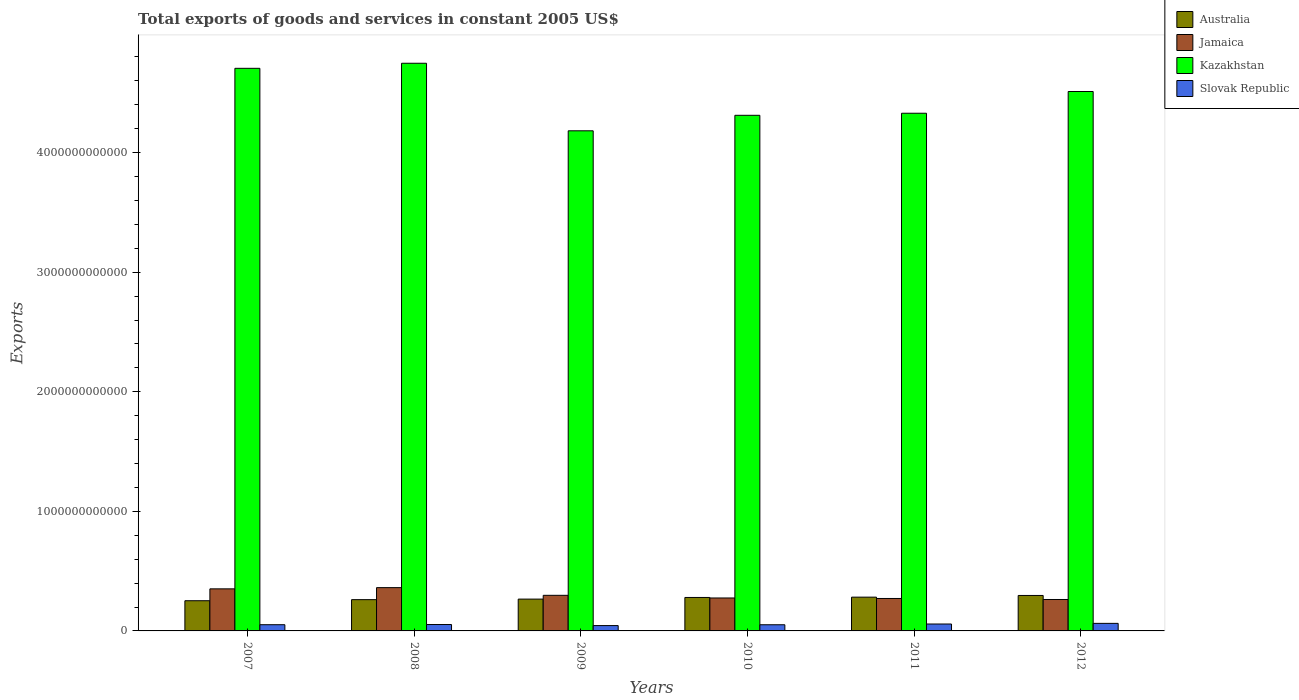How many different coloured bars are there?
Your answer should be compact. 4. Are the number of bars per tick equal to the number of legend labels?
Keep it short and to the point. Yes. How many bars are there on the 6th tick from the left?
Give a very brief answer. 4. What is the total exports of goods and services in Slovak Republic in 2010?
Ensure brevity in your answer.  5.16e+1. Across all years, what is the maximum total exports of goods and services in Australia?
Your answer should be very brief. 2.96e+11. Across all years, what is the minimum total exports of goods and services in Slovak Republic?
Make the answer very short. 4.46e+1. What is the total total exports of goods and services in Kazakhstan in the graph?
Give a very brief answer. 2.68e+13. What is the difference between the total exports of goods and services in Australia in 2008 and that in 2011?
Your answer should be very brief. -2.09e+1. What is the difference between the total exports of goods and services in Kazakhstan in 2007 and the total exports of goods and services in Slovak Republic in 2012?
Give a very brief answer. 4.64e+12. What is the average total exports of goods and services in Kazakhstan per year?
Keep it short and to the point. 4.46e+12. In the year 2009, what is the difference between the total exports of goods and services in Australia and total exports of goods and services in Slovak Republic?
Your answer should be very brief. 2.22e+11. In how many years, is the total exports of goods and services in Slovak Republic greater than 3200000000000 US$?
Offer a terse response. 0. What is the ratio of the total exports of goods and services in Australia in 2008 to that in 2012?
Your answer should be compact. 0.88. Is the difference between the total exports of goods and services in Australia in 2008 and 2011 greater than the difference between the total exports of goods and services in Slovak Republic in 2008 and 2011?
Provide a short and direct response. No. What is the difference between the highest and the second highest total exports of goods and services in Australia?
Offer a terse response. 1.41e+1. What is the difference between the highest and the lowest total exports of goods and services in Jamaica?
Give a very brief answer. 9.93e+1. In how many years, is the total exports of goods and services in Australia greater than the average total exports of goods and services in Australia taken over all years?
Offer a very short reply. 3. Is it the case that in every year, the sum of the total exports of goods and services in Slovak Republic and total exports of goods and services in Jamaica is greater than the sum of total exports of goods and services in Kazakhstan and total exports of goods and services in Australia?
Offer a terse response. Yes. What does the 3rd bar from the left in 2009 represents?
Offer a terse response. Kazakhstan. What does the 3rd bar from the right in 2007 represents?
Your response must be concise. Jamaica. Is it the case that in every year, the sum of the total exports of goods and services in Slovak Republic and total exports of goods and services in Australia is greater than the total exports of goods and services in Jamaica?
Your answer should be very brief. No. How many bars are there?
Keep it short and to the point. 24. Are all the bars in the graph horizontal?
Make the answer very short. No. What is the difference between two consecutive major ticks on the Y-axis?
Provide a succinct answer. 1.00e+12. Does the graph contain any zero values?
Offer a terse response. No. What is the title of the graph?
Your answer should be compact. Total exports of goods and services in constant 2005 US$. Does "Canada" appear as one of the legend labels in the graph?
Ensure brevity in your answer.  No. What is the label or title of the Y-axis?
Offer a terse response. Exports. What is the Exports in Australia in 2007?
Offer a very short reply. 2.53e+11. What is the Exports in Jamaica in 2007?
Provide a short and direct response. 3.52e+11. What is the Exports in Kazakhstan in 2007?
Give a very brief answer. 4.70e+12. What is the Exports in Slovak Republic in 2007?
Keep it short and to the point. 5.20e+1. What is the Exports of Australia in 2008?
Give a very brief answer. 2.62e+11. What is the Exports of Jamaica in 2008?
Ensure brevity in your answer.  3.62e+11. What is the Exports in Kazakhstan in 2008?
Keep it short and to the point. 4.75e+12. What is the Exports of Slovak Republic in 2008?
Offer a very short reply. 5.35e+1. What is the Exports of Australia in 2009?
Offer a terse response. 2.66e+11. What is the Exports in Jamaica in 2009?
Your answer should be compact. 2.98e+11. What is the Exports in Kazakhstan in 2009?
Provide a short and direct response. 4.18e+12. What is the Exports of Slovak Republic in 2009?
Provide a succinct answer. 4.46e+1. What is the Exports of Australia in 2010?
Keep it short and to the point. 2.80e+11. What is the Exports in Jamaica in 2010?
Give a very brief answer. 2.76e+11. What is the Exports in Kazakhstan in 2010?
Give a very brief answer. 4.31e+12. What is the Exports of Slovak Republic in 2010?
Provide a succinct answer. 5.16e+1. What is the Exports of Australia in 2011?
Your response must be concise. 2.82e+11. What is the Exports in Jamaica in 2011?
Your response must be concise. 2.71e+11. What is the Exports of Kazakhstan in 2011?
Ensure brevity in your answer.  4.33e+12. What is the Exports of Slovak Republic in 2011?
Offer a terse response. 5.78e+1. What is the Exports in Australia in 2012?
Make the answer very short. 2.96e+11. What is the Exports in Jamaica in 2012?
Your answer should be very brief. 2.63e+11. What is the Exports in Kazakhstan in 2012?
Provide a short and direct response. 4.51e+12. What is the Exports of Slovak Republic in 2012?
Make the answer very short. 6.32e+1. Across all years, what is the maximum Exports in Australia?
Ensure brevity in your answer.  2.96e+11. Across all years, what is the maximum Exports of Jamaica?
Provide a short and direct response. 3.62e+11. Across all years, what is the maximum Exports of Kazakhstan?
Provide a succinct answer. 4.75e+12. Across all years, what is the maximum Exports of Slovak Republic?
Make the answer very short. 6.32e+1. Across all years, what is the minimum Exports in Australia?
Your answer should be compact. 2.53e+11. Across all years, what is the minimum Exports of Jamaica?
Offer a terse response. 2.63e+11. Across all years, what is the minimum Exports in Kazakhstan?
Give a very brief answer. 4.18e+12. Across all years, what is the minimum Exports in Slovak Republic?
Your response must be concise. 4.46e+1. What is the total Exports of Australia in the graph?
Make the answer very short. 1.64e+12. What is the total Exports in Jamaica in the graph?
Provide a short and direct response. 1.82e+12. What is the total Exports of Kazakhstan in the graph?
Make the answer very short. 2.68e+13. What is the total Exports of Slovak Republic in the graph?
Your answer should be very brief. 3.23e+11. What is the difference between the Exports in Australia in 2007 and that in 2008?
Give a very brief answer. -8.97e+09. What is the difference between the Exports in Jamaica in 2007 and that in 2008?
Provide a short and direct response. -1.02e+1. What is the difference between the Exports of Kazakhstan in 2007 and that in 2008?
Offer a very short reply. -4.23e+1. What is the difference between the Exports of Slovak Republic in 2007 and that in 2008?
Offer a very short reply. -1.57e+09. What is the difference between the Exports of Australia in 2007 and that in 2009?
Provide a succinct answer. -1.36e+1. What is the difference between the Exports in Jamaica in 2007 and that in 2009?
Your answer should be very brief. 5.41e+1. What is the difference between the Exports in Kazakhstan in 2007 and that in 2009?
Your answer should be compact. 5.23e+11. What is the difference between the Exports of Slovak Republic in 2007 and that in 2009?
Your response must be concise. 7.41e+09. What is the difference between the Exports of Australia in 2007 and that in 2010?
Provide a succinct answer. -2.72e+1. What is the difference between the Exports of Jamaica in 2007 and that in 2010?
Ensure brevity in your answer.  7.63e+1. What is the difference between the Exports of Kazakhstan in 2007 and that in 2010?
Your response must be concise. 3.93e+11. What is the difference between the Exports in Slovak Republic in 2007 and that in 2010?
Provide a short and direct response. 3.94e+08. What is the difference between the Exports in Australia in 2007 and that in 2011?
Your response must be concise. -2.98e+1. What is the difference between the Exports of Jamaica in 2007 and that in 2011?
Provide a short and direct response. 8.05e+1. What is the difference between the Exports of Kazakhstan in 2007 and that in 2011?
Make the answer very short. 3.76e+11. What is the difference between the Exports in Slovak Republic in 2007 and that in 2011?
Offer a terse response. -5.80e+09. What is the difference between the Exports of Australia in 2007 and that in 2012?
Provide a succinct answer. -4.40e+1. What is the difference between the Exports in Jamaica in 2007 and that in 2012?
Ensure brevity in your answer.  8.91e+1. What is the difference between the Exports of Kazakhstan in 2007 and that in 2012?
Keep it short and to the point. 1.94e+11. What is the difference between the Exports in Slovak Republic in 2007 and that in 2012?
Ensure brevity in your answer.  -1.12e+1. What is the difference between the Exports of Australia in 2008 and that in 2009?
Your answer should be compact. -4.58e+09. What is the difference between the Exports of Jamaica in 2008 and that in 2009?
Keep it short and to the point. 6.43e+1. What is the difference between the Exports in Kazakhstan in 2008 and that in 2009?
Offer a terse response. 5.65e+11. What is the difference between the Exports of Slovak Republic in 2008 and that in 2009?
Your answer should be compact. 8.98e+09. What is the difference between the Exports in Australia in 2008 and that in 2010?
Your answer should be compact. -1.83e+1. What is the difference between the Exports of Jamaica in 2008 and that in 2010?
Your response must be concise. 8.65e+1. What is the difference between the Exports in Kazakhstan in 2008 and that in 2010?
Your answer should be very brief. 4.35e+11. What is the difference between the Exports of Slovak Republic in 2008 and that in 2010?
Your response must be concise. 1.96e+09. What is the difference between the Exports of Australia in 2008 and that in 2011?
Keep it short and to the point. -2.09e+1. What is the difference between the Exports in Jamaica in 2008 and that in 2011?
Keep it short and to the point. 9.07e+1. What is the difference between the Exports in Kazakhstan in 2008 and that in 2011?
Offer a terse response. 4.18e+11. What is the difference between the Exports of Slovak Republic in 2008 and that in 2011?
Your response must be concise. -4.23e+09. What is the difference between the Exports in Australia in 2008 and that in 2012?
Your answer should be compact. -3.50e+1. What is the difference between the Exports of Jamaica in 2008 and that in 2012?
Give a very brief answer. 9.93e+1. What is the difference between the Exports of Kazakhstan in 2008 and that in 2012?
Provide a short and direct response. 2.36e+11. What is the difference between the Exports in Slovak Republic in 2008 and that in 2012?
Your answer should be very brief. -9.61e+09. What is the difference between the Exports in Australia in 2009 and that in 2010?
Offer a terse response. -1.37e+1. What is the difference between the Exports in Jamaica in 2009 and that in 2010?
Your answer should be very brief. 2.22e+1. What is the difference between the Exports in Kazakhstan in 2009 and that in 2010?
Your answer should be very brief. -1.30e+11. What is the difference between the Exports in Slovak Republic in 2009 and that in 2010?
Provide a succinct answer. -7.01e+09. What is the difference between the Exports of Australia in 2009 and that in 2011?
Your answer should be compact. -1.63e+1. What is the difference between the Exports in Jamaica in 2009 and that in 2011?
Give a very brief answer. 2.64e+1. What is the difference between the Exports of Kazakhstan in 2009 and that in 2011?
Offer a terse response. -1.47e+11. What is the difference between the Exports in Slovak Republic in 2009 and that in 2011?
Your response must be concise. -1.32e+1. What is the difference between the Exports in Australia in 2009 and that in 2012?
Provide a succinct answer. -3.04e+1. What is the difference between the Exports of Jamaica in 2009 and that in 2012?
Provide a succinct answer. 3.50e+1. What is the difference between the Exports in Kazakhstan in 2009 and that in 2012?
Give a very brief answer. -3.29e+11. What is the difference between the Exports in Slovak Republic in 2009 and that in 2012?
Your answer should be very brief. -1.86e+1. What is the difference between the Exports of Australia in 2010 and that in 2011?
Make the answer very short. -2.60e+09. What is the difference between the Exports in Jamaica in 2010 and that in 2011?
Ensure brevity in your answer.  4.18e+09. What is the difference between the Exports of Kazakhstan in 2010 and that in 2011?
Your answer should be very brief. -1.72e+1. What is the difference between the Exports in Slovak Republic in 2010 and that in 2011?
Keep it short and to the point. -6.19e+09. What is the difference between the Exports in Australia in 2010 and that in 2012?
Give a very brief answer. -1.67e+1. What is the difference between the Exports of Jamaica in 2010 and that in 2012?
Offer a very short reply. 1.28e+1. What is the difference between the Exports in Kazakhstan in 2010 and that in 2012?
Keep it short and to the point. -1.99e+11. What is the difference between the Exports of Slovak Republic in 2010 and that in 2012?
Your answer should be compact. -1.16e+1. What is the difference between the Exports of Australia in 2011 and that in 2012?
Ensure brevity in your answer.  -1.41e+1. What is the difference between the Exports of Jamaica in 2011 and that in 2012?
Keep it short and to the point. 8.60e+09. What is the difference between the Exports in Kazakhstan in 2011 and that in 2012?
Your answer should be very brief. -1.82e+11. What is the difference between the Exports in Slovak Republic in 2011 and that in 2012?
Offer a very short reply. -5.38e+09. What is the difference between the Exports of Australia in 2007 and the Exports of Jamaica in 2008?
Ensure brevity in your answer.  -1.10e+11. What is the difference between the Exports of Australia in 2007 and the Exports of Kazakhstan in 2008?
Keep it short and to the point. -4.49e+12. What is the difference between the Exports in Australia in 2007 and the Exports in Slovak Republic in 2008?
Provide a succinct answer. 1.99e+11. What is the difference between the Exports in Jamaica in 2007 and the Exports in Kazakhstan in 2008?
Give a very brief answer. -4.40e+12. What is the difference between the Exports of Jamaica in 2007 and the Exports of Slovak Republic in 2008?
Your answer should be very brief. 2.98e+11. What is the difference between the Exports of Kazakhstan in 2007 and the Exports of Slovak Republic in 2008?
Your response must be concise. 4.65e+12. What is the difference between the Exports of Australia in 2007 and the Exports of Jamaica in 2009?
Provide a short and direct response. -4.52e+1. What is the difference between the Exports of Australia in 2007 and the Exports of Kazakhstan in 2009?
Your answer should be very brief. -3.93e+12. What is the difference between the Exports of Australia in 2007 and the Exports of Slovak Republic in 2009?
Provide a short and direct response. 2.08e+11. What is the difference between the Exports in Jamaica in 2007 and the Exports in Kazakhstan in 2009?
Ensure brevity in your answer.  -3.83e+12. What is the difference between the Exports of Jamaica in 2007 and the Exports of Slovak Republic in 2009?
Provide a short and direct response. 3.07e+11. What is the difference between the Exports in Kazakhstan in 2007 and the Exports in Slovak Republic in 2009?
Your answer should be very brief. 4.66e+12. What is the difference between the Exports in Australia in 2007 and the Exports in Jamaica in 2010?
Provide a short and direct response. -2.30e+1. What is the difference between the Exports in Australia in 2007 and the Exports in Kazakhstan in 2010?
Make the answer very short. -4.06e+12. What is the difference between the Exports of Australia in 2007 and the Exports of Slovak Republic in 2010?
Your answer should be very brief. 2.01e+11. What is the difference between the Exports of Jamaica in 2007 and the Exports of Kazakhstan in 2010?
Offer a very short reply. -3.96e+12. What is the difference between the Exports in Jamaica in 2007 and the Exports in Slovak Republic in 2010?
Your answer should be compact. 3.00e+11. What is the difference between the Exports of Kazakhstan in 2007 and the Exports of Slovak Republic in 2010?
Your response must be concise. 4.65e+12. What is the difference between the Exports in Australia in 2007 and the Exports in Jamaica in 2011?
Ensure brevity in your answer.  -1.88e+1. What is the difference between the Exports of Australia in 2007 and the Exports of Kazakhstan in 2011?
Your answer should be very brief. -4.08e+12. What is the difference between the Exports of Australia in 2007 and the Exports of Slovak Republic in 2011?
Give a very brief answer. 1.95e+11. What is the difference between the Exports in Jamaica in 2007 and the Exports in Kazakhstan in 2011?
Offer a terse response. -3.98e+12. What is the difference between the Exports of Jamaica in 2007 and the Exports of Slovak Republic in 2011?
Make the answer very short. 2.94e+11. What is the difference between the Exports of Kazakhstan in 2007 and the Exports of Slovak Republic in 2011?
Make the answer very short. 4.65e+12. What is the difference between the Exports in Australia in 2007 and the Exports in Jamaica in 2012?
Ensure brevity in your answer.  -1.02e+1. What is the difference between the Exports of Australia in 2007 and the Exports of Kazakhstan in 2012?
Your answer should be very brief. -4.26e+12. What is the difference between the Exports of Australia in 2007 and the Exports of Slovak Republic in 2012?
Ensure brevity in your answer.  1.89e+11. What is the difference between the Exports in Jamaica in 2007 and the Exports in Kazakhstan in 2012?
Offer a terse response. -4.16e+12. What is the difference between the Exports in Jamaica in 2007 and the Exports in Slovak Republic in 2012?
Your answer should be compact. 2.89e+11. What is the difference between the Exports in Kazakhstan in 2007 and the Exports in Slovak Republic in 2012?
Offer a very short reply. 4.64e+12. What is the difference between the Exports in Australia in 2008 and the Exports in Jamaica in 2009?
Offer a very short reply. -3.63e+1. What is the difference between the Exports in Australia in 2008 and the Exports in Kazakhstan in 2009?
Keep it short and to the point. -3.92e+12. What is the difference between the Exports in Australia in 2008 and the Exports in Slovak Republic in 2009?
Ensure brevity in your answer.  2.17e+11. What is the difference between the Exports in Jamaica in 2008 and the Exports in Kazakhstan in 2009?
Your answer should be very brief. -3.82e+12. What is the difference between the Exports of Jamaica in 2008 and the Exports of Slovak Republic in 2009?
Give a very brief answer. 3.17e+11. What is the difference between the Exports of Kazakhstan in 2008 and the Exports of Slovak Republic in 2009?
Keep it short and to the point. 4.70e+12. What is the difference between the Exports in Australia in 2008 and the Exports in Jamaica in 2010?
Offer a terse response. -1.40e+1. What is the difference between the Exports of Australia in 2008 and the Exports of Kazakhstan in 2010?
Keep it short and to the point. -4.05e+12. What is the difference between the Exports of Australia in 2008 and the Exports of Slovak Republic in 2010?
Offer a terse response. 2.10e+11. What is the difference between the Exports of Jamaica in 2008 and the Exports of Kazakhstan in 2010?
Your answer should be very brief. -3.95e+12. What is the difference between the Exports in Jamaica in 2008 and the Exports in Slovak Republic in 2010?
Ensure brevity in your answer.  3.10e+11. What is the difference between the Exports of Kazakhstan in 2008 and the Exports of Slovak Republic in 2010?
Offer a terse response. 4.70e+12. What is the difference between the Exports of Australia in 2008 and the Exports of Jamaica in 2011?
Provide a short and direct response. -9.87e+09. What is the difference between the Exports of Australia in 2008 and the Exports of Kazakhstan in 2011?
Your answer should be very brief. -4.07e+12. What is the difference between the Exports in Australia in 2008 and the Exports in Slovak Republic in 2011?
Provide a succinct answer. 2.04e+11. What is the difference between the Exports of Jamaica in 2008 and the Exports of Kazakhstan in 2011?
Your answer should be very brief. -3.97e+12. What is the difference between the Exports of Jamaica in 2008 and the Exports of Slovak Republic in 2011?
Your response must be concise. 3.04e+11. What is the difference between the Exports of Kazakhstan in 2008 and the Exports of Slovak Republic in 2011?
Offer a very short reply. 4.69e+12. What is the difference between the Exports in Australia in 2008 and the Exports in Jamaica in 2012?
Offer a terse response. -1.27e+09. What is the difference between the Exports in Australia in 2008 and the Exports in Kazakhstan in 2012?
Offer a very short reply. -4.25e+12. What is the difference between the Exports in Australia in 2008 and the Exports in Slovak Republic in 2012?
Ensure brevity in your answer.  1.98e+11. What is the difference between the Exports of Jamaica in 2008 and the Exports of Kazakhstan in 2012?
Your answer should be compact. -4.15e+12. What is the difference between the Exports of Jamaica in 2008 and the Exports of Slovak Republic in 2012?
Your answer should be very brief. 2.99e+11. What is the difference between the Exports in Kazakhstan in 2008 and the Exports in Slovak Republic in 2012?
Provide a short and direct response. 4.68e+12. What is the difference between the Exports in Australia in 2009 and the Exports in Jamaica in 2010?
Offer a terse response. -9.47e+09. What is the difference between the Exports in Australia in 2009 and the Exports in Kazakhstan in 2010?
Your response must be concise. -4.05e+12. What is the difference between the Exports of Australia in 2009 and the Exports of Slovak Republic in 2010?
Provide a short and direct response. 2.15e+11. What is the difference between the Exports in Jamaica in 2009 and the Exports in Kazakhstan in 2010?
Give a very brief answer. -4.01e+12. What is the difference between the Exports in Jamaica in 2009 and the Exports in Slovak Republic in 2010?
Provide a short and direct response. 2.46e+11. What is the difference between the Exports of Kazakhstan in 2009 and the Exports of Slovak Republic in 2010?
Keep it short and to the point. 4.13e+12. What is the difference between the Exports in Australia in 2009 and the Exports in Jamaica in 2011?
Your answer should be very brief. -5.29e+09. What is the difference between the Exports in Australia in 2009 and the Exports in Kazakhstan in 2011?
Make the answer very short. -4.06e+12. What is the difference between the Exports in Australia in 2009 and the Exports in Slovak Republic in 2011?
Your answer should be very brief. 2.08e+11. What is the difference between the Exports in Jamaica in 2009 and the Exports in Kazakhstan in 2011?
Ensure brevity in your answer.  -4.03e+12. What is the difference between the Exports in Jamaica in 2009 and the Exports in Slovak Republic in 2011?
Provide a short and direct response. 2.40e+11. What is the difference between the Exports of Kazakhstan in 2009 and the Exports of Slovak Republic in 2011?
Give a very brief answer. 4.12e+12. What is the difference between the Exports in Australia in 2009 and the Exports in Jamaica in 2012?
Your answer should be very brief. 3.31e+09. What is the difference between the Exports in Australia in 2009 and the Exports in Kazakhstan in 2012?
Provide a succinct answer. -4.24e+12. What is the difference between the Exports in Australia in 2009 and the Exports in Slovak Republic in 2012?
Offer a terse response. 2.03e+11. What is the difference between the Exports of Jamaica in 2009 and the Exports of Kazakhstan in 2012?
Your response must be concise. -4.21e+12. What is the difference between the Exports of Jamaica in 2009 and the Exports of Slovak Republic in 2012?
Offer a terse response. 2.35e+11. What is the difference between the Exports of Kazakhstan in 2009 and the Exports of Slovak Republic in 2012?
Provide a succinct answer. 4.12e+12. What is the difference between the Exports in Australia in 2010 and the Exports in Jamaica in 2011?
Offer a very short reply. 8.39e+09. What is the difference between the Exports of Australia in 2010 and the Exports of Kazakhstan in 2011?
Provide a short and direct response. -4.05e+12. What is the difference between the Exports in Australia in 2010 and the Exports in Slovak Republic in 2011?
Give a very brief answer. 2.22e+11. What is the difference between the Exports in Jamaica in 2010 and the Exports in Kazakhstan in 2011?
Keep it short and to the point. -4.05e+12. What is the difference between the Exports in Jamaica in 2010 and the Exports in Slovak Republic in 2011?
Your answer should be very brief. 2.18e+11. What is the difference between the Exports of Kazakhstan in 2010 and the Exports of Slovak Republic in 2011?
Offer a very short reply. 4.25e+12. What is the difference between the Exports of Australia in 2010 and the Exports of Jamaica in 2012?
Your answer should be compact. 1.70e+1. What is the difference between the Exports of Australia in 2010 and the Exports of Kazakhstan in 2012?
Your answer should be compact. -4.23e+12. What is the difference between the Exports in Australia in 2010 and the Exports in Slovak Republic in 2012?
Keep it short and to the point. 2.17e+11. What is the difference between the Exports of Jamaica in 2010 and the Exports of Kazakhstan in 2012?
Ensure brevity in your answer.  -4.24e+12. What is the difference between the Exports in Jamaica in 2010 and the Exports in Slovak Republic in 2012?
Offer a very short reply. 2.12e+11. What is the difference between the Exports of Kazakhstan in 2010 and the Exports of Slovak Republic in 2012?
Make the answer very short. 4.25e+12. What is the difference between the Exports in Australia in 2011 and the Exports in Jamaica in 2012?
Keep it short and to the point. 1.96e+1. What is the difference between the Exports of Australia in 2011 and the Exports of Kazakhstan in 2012?
Offer a very short reply. -4.23e+12. What is the difference between the Exports of Australia in 2011 and the Exports of Slovak Republic in 2012?
Offer a terse response. 2.19e+11. What is the difference between the Exports of Jamaica in 2011 and the Exports of Kazakhstan in 2012?
Your answer should be compact. -4.24e+12. What is the difference between the Exports in Jamaica in 2011 and the Exports in Slovak Republic in 2012?
Your answer should be very brief. 2.08e+11. What is the difference between the Exports of Kazakhstan in 2011 and the Exports of Slovak Republic in 2012?
Offer a terse response. 4.27e+12. What is the average Exports in Australia per year?
Provide a succinct answer. 2.73e+11. What is the average Exports in Jamaica per year?
Ensure brevity in your answer.  3.04e+11. What is the average Exports of Kazakhstan per year?
Your answer should be very brief. 4.46e+12. What is the average Exports of Slovak Republic per year?
Your response must be concise. 5.38e+1. In the year 2007, what is the difference between the Exports in Australia and Exports in Jamaica?
Keep it short and to the point. -9.93e+1. In the year 2007, what is the difference between the Exports of Australia and Exports of Kazakhstan?
Your answer should be very brief. -4.45e+12. In the year 2007, what is the difference between the Exports of Australia and Exports of Slovak Republic?
Offer a very short reply. 2.01e+11. In the year 2007, what is the difference between the Exports of Jamaica and Exports of Kazakhstan?
Give a very brief answer. -4.35e+12. In the year 2007, what is the difference between the Exports of Jamaica and Exports of Slovak Republic?
Your answer should be compact. 3.00e+11. In the year 2007, what is the difference between the Exports of Kazakhstan and Exports of Slovak Republic?
Offer a very short reply. 4.65e+12. In the year 2008, what is the difference between the Exports of Australia and Exports of Jamaica?
Give a very brief answer. -1.01e+11. In the year 2008, what is the difference between the Exports of Australia and Exports of Kazakhstan?
Your answer should be compact. -4.49e+12. In the year 2008, what is the difference between the Exports in Australia and Exports in Slovak Republic?
Make the answer very short. 2.08e+11. In the year 2008, what is the difference between the Exports of Jamaica and Exports of Kazakhstan?
Your response must be concise. -4.39e+12. In the year 2008, what is the difference between the Exports of Jamaica and Exports of Slovak Republic?
Give a very brief answer. 3.09e+11. In the year 2008, what is the difference between the Exports of Kazakhstan and Exports of Slovak Republic?
Provide a succinct answer. 4.69e+12. In the year 2009, what is the difference between the Exports of Australia and Exports of Jamaica?
Your response must be concise. -3.17e+1. In the year 2009, what is the difference between the Exports in Australia and Exports in Kazakhstan?
Give a very brief answer. -3.92e+12. In the year 2009, what is the difference between the Exports in Australia and Exports in Slovak Republic?
Your response must be concise. 2.22e+11. In the year 2009, what is the difference between the Exports of Jamaica and Exports of Kazakhstan?
Your response must be concise. -3.88e+12. In the year 2009, what is the difference between the Exports in Jamaica and Exports in Slovak Republic?
Keep it short and to the point. 2.53e+11. In the year 2009, what is the difference between the Exports in Kazakhstan and Exports in Slovak Republic?
Provide a succinct answer. 4.14e+12. In the year 2010, what is the difference between the Exports in Australia and Exports in Jamaica?
Your answer should be very brief. 4.21e+09. In the year 2010, what is the difference between the Exports of Australia and Exports of Kazakhstan?
Provide a short and direct response. -4.03e+12. In the year 2010, what is the difference between the Exports in Australia and Exports in Slovak Republic?
Give a very brief answer. 2.28e+11. In the year 2010, what is the difference between the Exports in Jamaica and Exports in Kazakhstan?
Provide a succinct answer. -4.04e+12. In the year 2010, what is the difference between the Exports in Jamaica and Exports in Slovak Republic?
Your answer should be compact. 2.24e+11. In the year 2010, what is the difference between the Exports in Kazakhstan and Exports in Slovak Republic?
Ensure brevity in your answer.  4.26e+12. In the year 2011, what is the difference between the Exports of Australia and Exports of Jamaica?
Ensure brevity in your answer.  1.10e+1. In the year 2011, what is the difference between the Exports in Australia and Exports in Kazakhstan?
Provide a succinct answer. -4.05e+12. In the year 2011, what is the difference between the Exports of Australia and Exports of Slovak Republic?
Give a very brief answer. 2.25e+11. In the year 2011, what is the difference between the Exports of Jamaica and Exports of Kazakhstan?
Give a very brief answer. -4.06e+12. In the year 2011, what is the difference between the Exports in Jamaica and Exports in Slovak Republic?
Make the answer very short. 2.14e+11. In the year 2011, what is the difference between the Exports in Kazakhstan and Exports in Slovak Republic?
Offer a terse response. 4.27e+12. In the year 2012, what is the difference between the Exports of Australia and Exports of Jamaica?
Your response must be concise. 3.37e+1. In the year 2012, what is the difference between the Exports of Australia and Exports of Kazakhstan?
Give a very brief answer. -4.21e+12. In the year 2012, what is the difference between the Exports of Australia and Exports of Slovak Republic?
Give a very brief answer. 2.33e+11. In the year 2012, what is the difference between the Exports of Jamaica and Exports of Kazakhstan?
Ensure brevity in your answer.  -4.25e+12. In the year 2012, what is the difference between the Exports of Jamaica and Exports of Slovak Republic?
Offer a very short reply. 2.00e+11. In the year 2012, what is the difference between the Exports in Kazakhstan and Exports in Slovak Republic?
Offer a very short reply. 4.45e+12. What is the ratio of the Exports of Australia in 2007 to that in 2008?
Your response must be concise. 0.97. What is the ratio of the Exports in Jamaica in 2007 to that in 2008?
Your answer should be compact. 0.97. What is the ratio of the Exports in Kazakhstan in 2007 to that in 2008?
Offer a very short reply. 0.99. What is the ratio of the Exports in Slovak Republic in 2007 to that in 2008?
Make the answer very short. 0.97. What is the ratio of the Exports of Australia in 2007 to that in 2009?
Ensure brevity in your answer.  0.95. What is the ratio of the Exports of Jamaica in 2007 to that in 2009?
Make the answer very short. 1.18. What is the ratio of the Exports in Kazakhstan in 2007 to that in 2009?
Give a very brief answer. 1.12. What is the ratio of the Exports in Slovak Republic in 2007 to that in 2009?
Your response must be concise. 1.17. What is the ratio of the Exports of Australia in 2007 to that in 2010?
Provide a short and direct response. 0.9. What is the ratio of the Exports in Jamaica in 2007 to that in 2010?
Your response must be concise. 1.28. What is the ratio of the Exports in Kazakhstan in 2007 to that in 2010?
Provide a short and direct response. 1.09. What is the ratio of the Exports of Slovak Republic in 2007 to that in 2010?
Your answer should be very brief. 1.01. What is the ratio of the Exports of Australia in 2007 to that in 2011?
Give a very brief answer. 0.89. What is the ratio of the Exports of Jamaica in 2007 to that in 2011?
Offer a very short reply. 1.3. What is the ratio of the Exports in Kazakhstan in 2007 to that in 2011?
Your answer should be compact. 1.09. What is the ratio of the Exports of Slovak Republic in 2007 to that in 2011?
Provide a succinct answer. 0.9. What is the ratio of the Exports of Australia in 2007 to that in 2012?
Make the answer very short. 0.85. What is the ratio of the Exports in Jamaica in 2007 to that in 2012?
Offer a terse response. 1.34. What is the ratio of the Exports in Kazakhstan in 2007 to that in 2012?
Offer a very short reply. 1.04. What is the ratio of the Exports in Slovak Republic in 2007 to that in 2012?
Make the answer very short. 0.82. What is the ratio of the Exports of Australia in 2008 to that in 2009?
Offer a terse response. 0.98. What is the ratio of the Exports in Jamaica in 2008 to that in 2009?
Offer a terse response. 1.22. What is the ratio of the Exports in Kazakhstan in 2008 to that in 2009?
Your response must be concise. 1.14. What is the ratio of the Exports in Slovak Republic in 2008 to that in 2009?
Ensure brevity in your answer.  1.2. What is the ratio of the Exports of Australia in 2008 to that in 2010?
Provide a short and direct response. 0.93. What is the ratio of the Exports in Jamaica in 2008 to that in 2010?
Ensure brevity in your answer.  1.31. What is the ratio of the Exports of Kazakhstan in 2008 to that in 2010?
Provide a short and direct response. 1.1. What is the ratio of the Exports of Slovak Republic in 2008 to that in 2010?
Make the answer very short. 1.04. What is the ratio of the Exports of Australia in 2008 to that in 2011?
Provide a short and direct response. 0.93. What is the ratio of the Exports in Jamaica in 2008 to that in 2011?
Ensure brevity in your answer.  1.33. What is the ratio of the Exports in Kazakhstan in 2008 to that in 2011?
Your response must be concise. 1.1. What is the ratio of the Exports of Slovak Republic in 2008 to that in 2011?
Your response must be concise. 0.93. What is the ratio of the Exports of Australia in 2008 to that in 2012?
Keep it short and to the point. 0.88. What is the ratio of the Exports of Jamaica in 2008 to that in 2012?
Your answer should be compact. 1.38. What is the ratio of the Exports of Kazakhstan in 2008 to that in 2012?
Your answer should be very brief. 1.05. What is the ratio of the Exports of Slovak Republic in 2008 to that in 2012?
Offer a very short reply. 0.85. What is the ratio of the Exports of Australia in 2009 to that in 2010?
Make the answer very short. 0.95. What is the ratio of the Exports in Jamaica in 2009 to that in 2010?
Keep it short and to the point. 1.08. What is the ratio of the Exports of Kazakhstan in 2009 to that in 2010?
Keep it short and to the point. 0.97. What is the ratio of the Exports in Slovak Republic in 2009 to that in 2010?
Your answer should be compact. 0.86. What is the ratio of the Exports of Australia in 2009 to that in 2011?
Offer a very short reply. 0.94. What is the ratio of the Exports of Jamaica in 2009 to that in 2011?
Ensure brevity in your answer.  1.1. What is the ratio of the Exports in Kazakhstan in 2009 to that in 2011?
Provide a succinct answer. 0.97. What is the ratio of the Exports of Slovak Republic in 2009 to that in 2011?
Offer a very short reply. 0.77. What is the ratio of the Exports in Australia in 2009 to that in 2012?
Offer a very short reply. 0.9. What is the ratio of the Exports in Jamaica in 2009 to that in 2012?
Your answer should be compact. 1.13. What is the ratio of the Exports of Kazakhstan in 2009 to that in 2012?
Ensure brevity in your answer.  0.93. What is the ratio of the Exports of Slovak Republic in 2009 to that in 2012?
Your answer should be very brief. 0.71. What is the ratio of the Exports of Australia in 2010 to that in 2011?
Offer a terse response. 0.99. What is the ratio of the Exports in Jamaica in 2010 to that in 2011?
Keep it short and to the point. 1.02. What is the ratio of the Exports in Slovak Republic in 2010 to that in 2011?
Provide a short and direct response. 0.89. What is the ratio of the Exports in Australia in 2010 to that in 2012?
Your answer should be very brief. 0.94. What is the ratio of the Exports of Jamaica in 2010 to that in 2012?
Offer a terse response. 1.05. What is the ratio of the Exports of Kazakhstan in 2010 to that in 2012?
Make the answer very short. 0.96. What is the ratio of the Exports in Slovak Republic in 2010 to that in 2012?
Your answer should be compact. 0.82. What is the ratio of the Exports in Australia in 2011 to that in 2012?
Your answer should be compact. 0.95. What is the ratio of the Exports of Jamaica in 2011 to that in 2012?
Ensure brevity in your answer.  1.03. What is the ratio of the Exports in Kazakhstan in 2011 to that in 2012?
Give a very brief answer. 0.96. What is the ratio of the Exports of Slovak Republic in 2011 to that in 2012?
Make the answer very short. 0.91. What is the difference between the highest and the second highest Exports of Australia?
Keep it short and to the point. 1.41e+1. What is the difference between the highest and the second highest Exports of Jamaica?
Give a very brief answer. 1.02e+1. What is the difference between the highest and the second highest Exports in Kazakhstan?
Offer a very short reply. 4.23e+1. What is the difference between the highest and the second highest Exports of Slovak Republic?
Offer a terse response. 5.38e+09. What is the difference between the highest and the lowest Exports in Australia?
Keep it short and to the point. 4.40e+1. What is the difference between the highest and the lowest Exports of Jamaica?
Give a very brief answer. 9.93e+1. What is the difference between the highest and the lowest Exports in Kazakhstan?
Your answer should be very brief. 5.65e+11. What is the difference between the highest and the lowest Exports of Slovak Republic?
Give a very brief answer. 1.86e+1. 